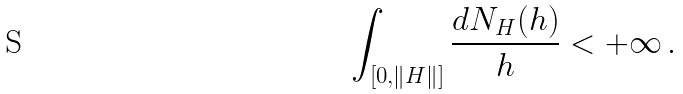<formula> <loc_0><loc_0><loc_500><loc_500>\int _ { [ 0 , \| H \| ] } \frac { d N _ { H } ( h ) } { h } < + \infty \, .</formula> 